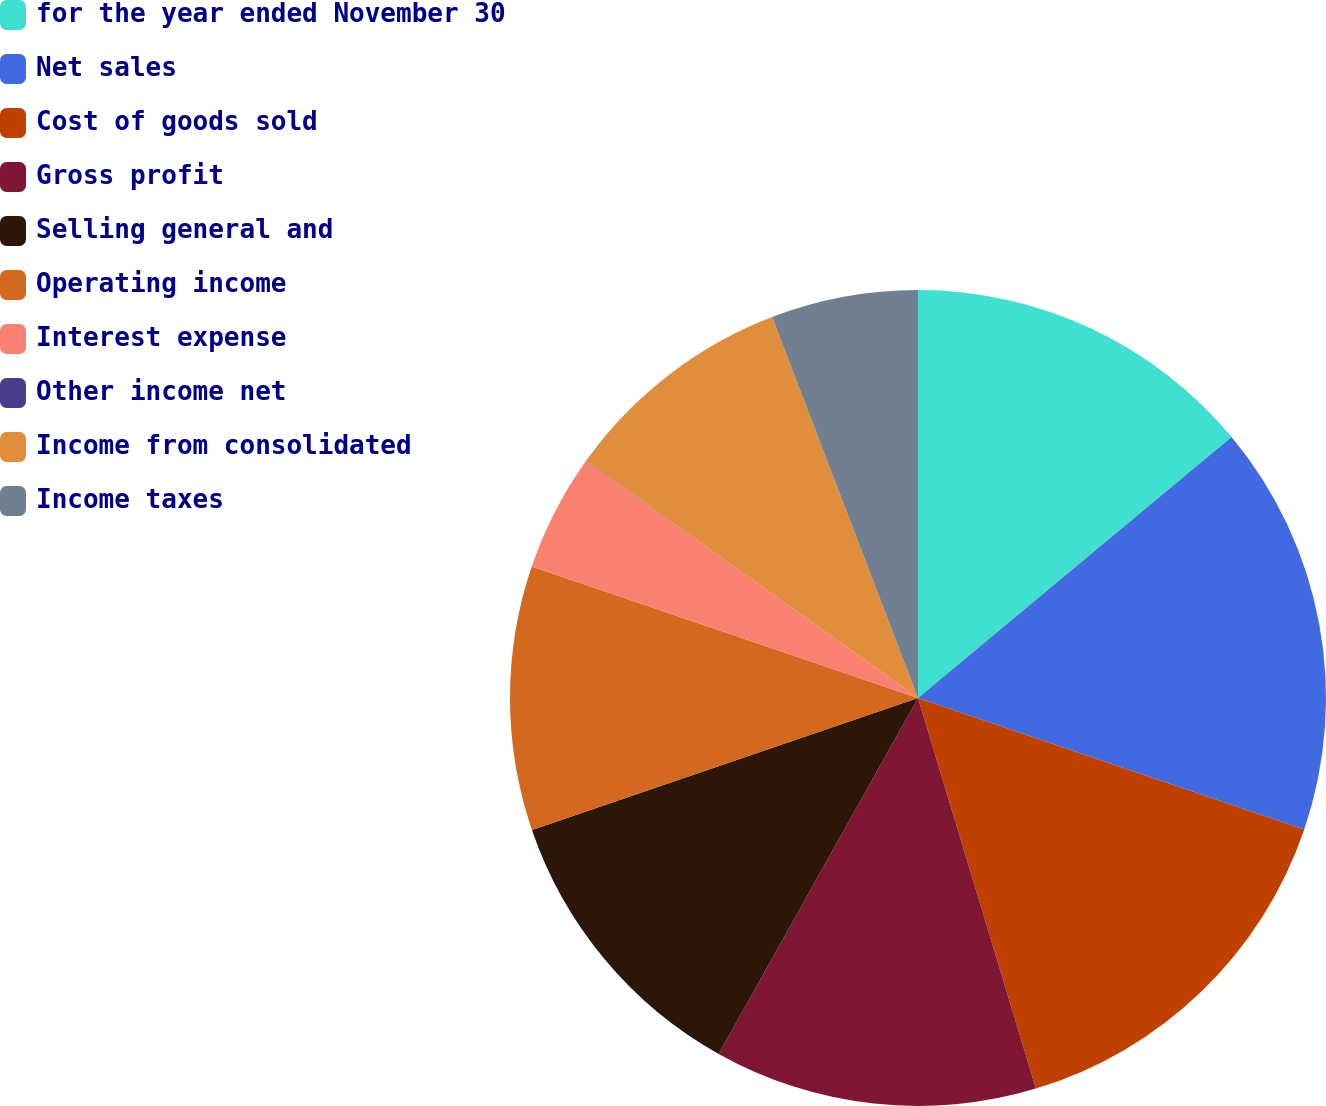Convert chart. <chart><loc_0><loc_0><loc_500><loc_500><pie_chart><fcel>for the year ended November 30<fcel>Net sales<fcel>Cost of goods sold<fcel>Gross profit<fcel>Selling general and<fcel>Operating income<fcel>Interest expense<fcel>Other income net<fcel>Income from consolidated<fcel>Income taxes<nl><fcel>13.95%<fcel>16.27%<fcel>15.11%<fcel>12.79%<fcel>11.63%<fcel>10.46%<fcel>4.65%<fcel>0.01%<fcel>9.3%<fcel>5.82%<nl></chart> 